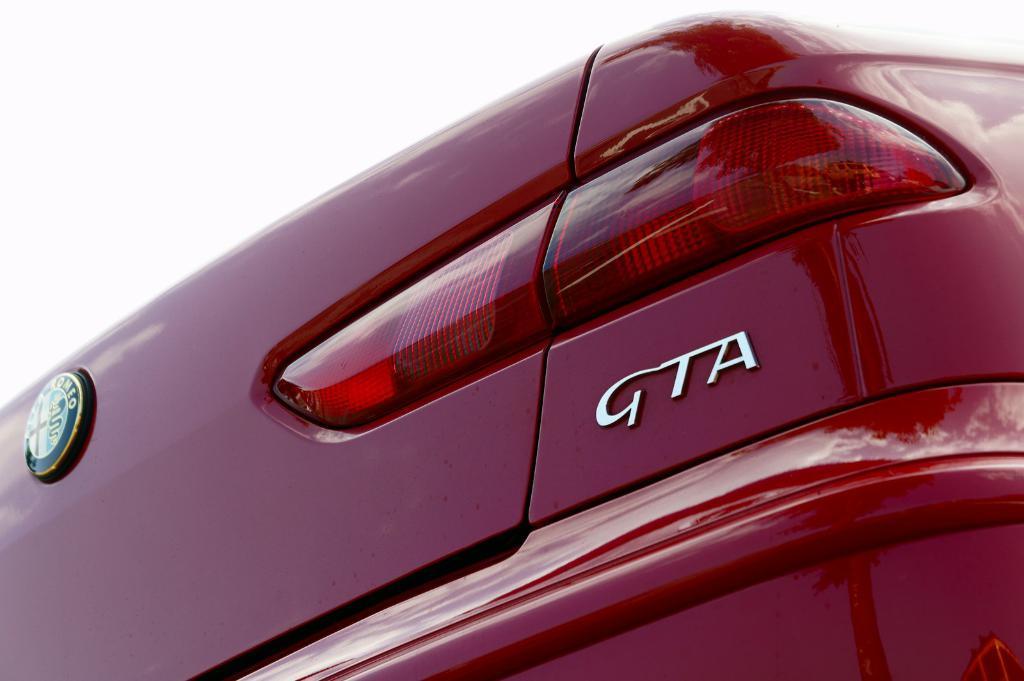Could you give a brief overview of what you see in this image? In this image I can see a vehicle part and some text written on that , at the top I can see white color background. 